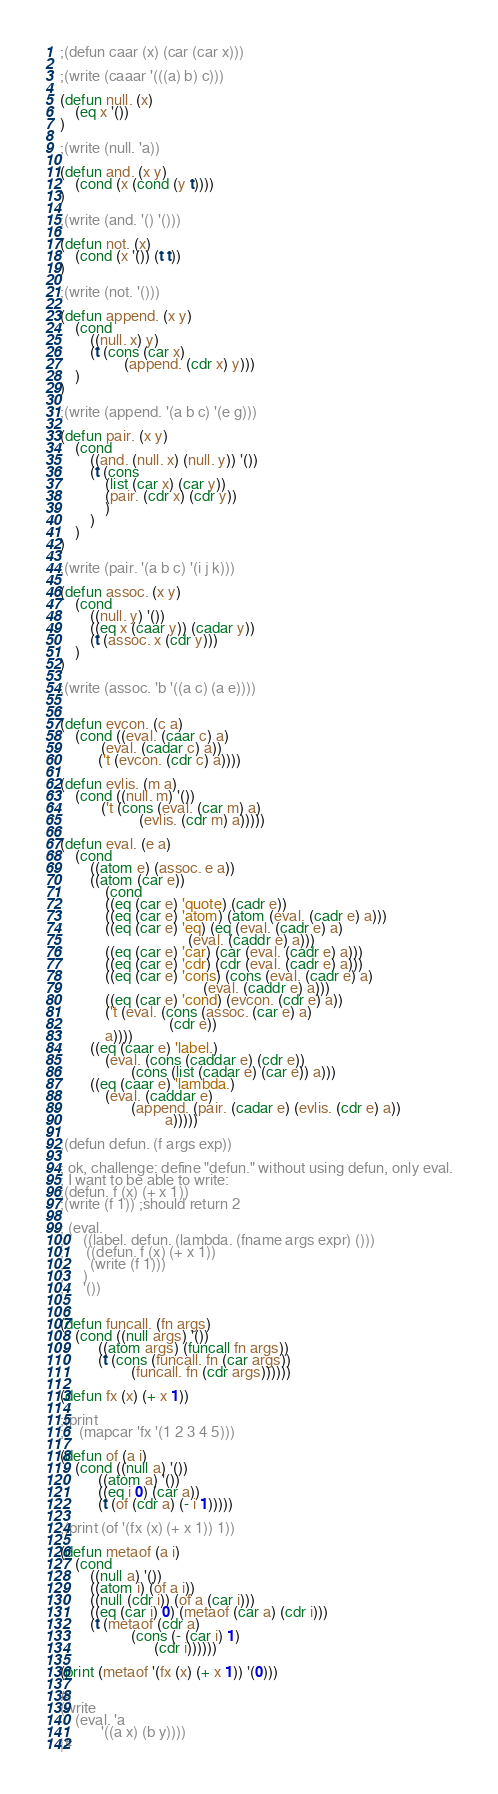Convert code to text. <code><loc_0><loc_0><loc_500><loc_500><_Lisp_>;(defun caar (x) (car (car x)))

;(write (caaar '(((a) b) c)))

(defun null. (x)
    (eq x '())
)

;(write (null. 'a))

(defun and. (x y)
    (cond (x (cond (y t))))
)

;(write (and. '() '()))

(defun not. (x)
    (cond (x '()) (t t))
)

;(write (not. '()))

(defun append. (x y)
    (cond 
        ((null. x) y)
        (t (cons (car x) 
                 (append. (cdr x) y)))
    )
)

;(write (append. '(a b c) '(e g)))

(defun pair. (x y)
    (cond
        ((and. (null. x) (null. y)) '())
        (t (cons 
            (list (car x) (car y))
            (pair. (cdr x) (cdr y))
            )
        )
    )
)

;(write (pair. '(a b c) '(i j k)))

(defun assoc. (x y)
    (cond
        ((null. y) '())
        ((eq x (caar y)) (cadar y))
        (t (assoc. x (cdr y)))
    )
)

;(write (assoc. 'b '((a c) (a e))))


(defun evcon. (c a)
    (cond ((eval. (caar c) a)
           (eval. (cadar c) a))
          ('t (evcon. (cdr c) a))))

(defun evlis. (m a)
    (cond ((null. m) '())
           ('t (cons (eval. (car m) a)
                     (evlis. (cdr m) a)))))

(defun eval. (e a)
    (cond
        ((atom e) (assoc. e a))
        ((atom (car e))
            (cond
            ((eq (car e) 'quote) (cadr e))
            ((eq (car e) 'atom) (atom (eval. (cadr e) a)))
            ((eq (car e) 'eq) (eq (eval. (cadr e) a)
                                  (eval. (caddr e) a)))
            ((eq (car e) 'car) (car (eval. (cadr e) a)))
            ((eq (car e) 'cdr) (cdr (eval. (cadr e) a)))
            ((eq (car e) 'cons) (cons (eval. (cadr e) a)
                                      (eval. (caddr e) a)))
            ((eq (car e) 'cond) (evcon. (cdr e) a))
            ('t (eval. (cons (assoc. (car e) a)
                             (cdr e))
            a))))
        ((eq (caar e) 'label.)
            (eval. (cons (caddar e) (cdr e))
                   (cons (list (cadar e) (car e)) a)))
        ((eq (caar e) 'lambda.)
            (eval. (caddar e)
                   (append. (pair. (cadar e) (evlis. (cdr e) a))
                            a)))))

;(defun defun. (f args exp))

; ok, challenge: define "defun." without using defun, only eval.
; I want to be able to write:
;(defun. f (x) (+ x 1))
;(write (f 1)) ;should return 2

; (eval. 
;     ((label. defun. (lambda. (fname args expr) ()))
;      ((defun. f (x) (+ x 1))
;       (write (f 1)))
;     ) 
;     '())


(defun funcall. (fn args)
    (cond ((null args) '())
          ((atom args) (funcall fn args))
          (t (cons (funcall. fn (car args)) 
                   (funcall. fn (cdr args))))))

(defun fx (x) (+ x 1))

;(print
;    (mapcar 'fx '(1 2 3 4 5)))

(defun of (a i)
    (cond ((null a) '())
          ((atom a) '())
          ((eq i 0) (car a))
          (t (of (cdr a) (- i 1)))))

;(print (of '(fx (x) (+ x 1)) 1))

(defun metaof (a i)
    (cond 
        ((null a) '())
        ((atom i) (of a i))
        ((null (cdr i)) (of a (car i)))
        ((eq (car i) 0) (metaof (car a) (cdr i))) 
        (t (metaof (cdr a) 
                   (cons (- (car i) 1) 
                         (cdr i))))))

(print (metaof '(fx (x) (+ x 1)) '(0)))

#|
(write 
    (eval. 'a 
           '((a x) (b y))))
|#

</code> 